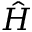<formula> <loc_0><loc_0><loc_500><loc_500>\hat { H }</formula> 